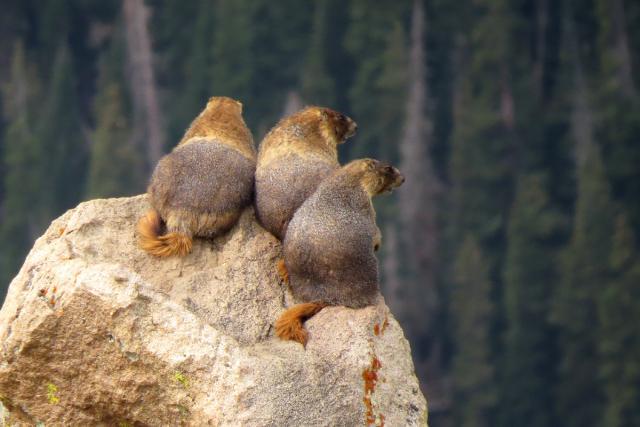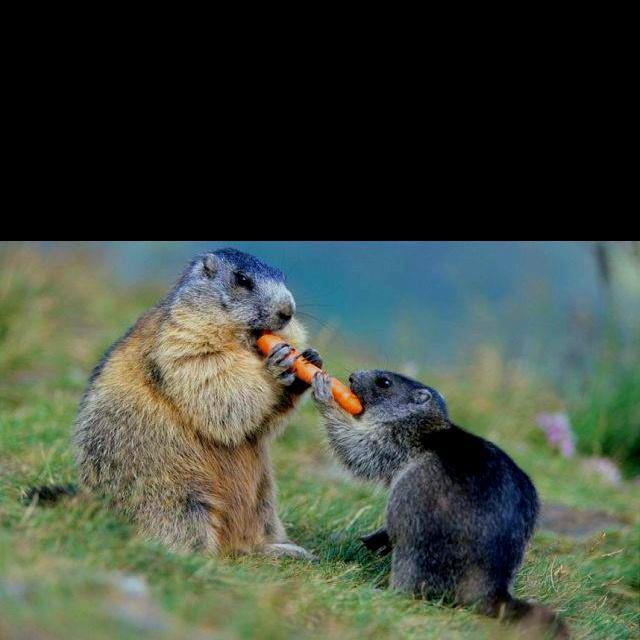The first image is the image on the left, the second image is the image on the right. Considering the images on both sides, is "Two animals are playing with each other in the image on the right." valid? Answer yes or no. Yes. 